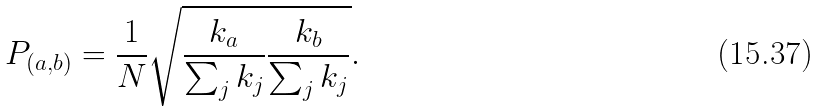Convert formula to latex. <formula><loc_0><loc_0><loc_500><loc_500>P _ { ( a , b ) } = \frac { 1 } { N } \sqrt { \frac { k _ { a } } { \sum _ { j } { k _ { j } } } \frac { k _ { b } } { \sum _ { j } { k _ { j } } } } .</formula> 